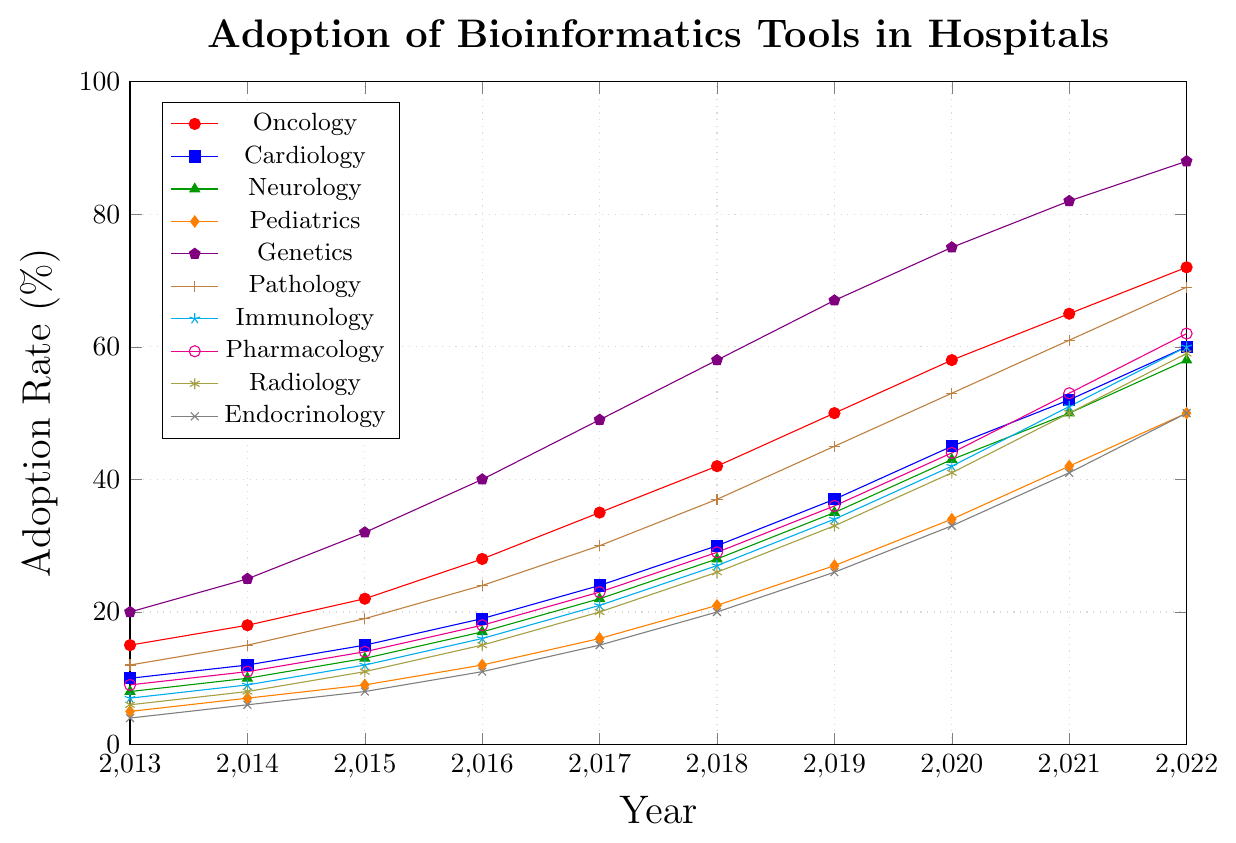What is the adoption rate of bioinformatics tools in Oncology in 2020? Look for the data point for Oncology in the year 2020 on the graph, which is marked in red and has the highest adoption rate among the lines.
Answer: 58% Which department had the lowest adoption rate in 2022? Compare the adoption rates of all departments in 2022 and identify the one with the lowest value. The lowest adoption rate in 2022 is for Endocrinology.
Answer: Endocrinology Between 2013 and 2018, which department saw the most significant increase in adoption rate? Calculate the difference in adoption rates between 2013 and 2018 for each department and compare them. Genetics saw the most significant increase, from 20% to 58%, i.e., an increase of 38%.
Answer: Genetics How does the adoption rate of Neurology in 2017 compare to Pediatrics in 2017? Compare the adoption rates for Neurology and Pediatrics in 2017. Neurology has an adoption rate of 22%, while Pediatrics has 16%.
Answer: Neurology is higher Which two departments had identical adoption rates in 2022? Scan the adoption rates in 2022 and identify the departments with matching values. Both Immunology and Cardiology had 60% in 2022.
Answer: Immunology and Cardiology What was the average adoption rate of bioinformatics tools across all departments in 2022? Sum all adoption rates for 2022 and then divide by the number of departments (10). The sum is 628%, and the average is 628/10 = 62.8%.
Answer: 62.8% By how much did the adoption rate in Pharmacology increase from 2015 to 2022? Subtract the adoption rate in 2015 from the rate in 2022 for Pharmacology. The increase is 62% - 14% = 48%.
Answer: 48% Which department had the fastest growth rate between 2019 and 2022? Calculate the growth rate for each department between 2019 and 2022 by subtracting the 2019 rate from the 2022 rate and compare these values. Genetics had the fastest growth rate, from 67% to 88%, an increase of 21%.
Answer: Genetics What was the median adoption rate of bioinformatics tools in 2013 across all departments? Arrange the 2013 adoption rates in numerical order and identify the middle value. The ordered rates are 4%, 5%, 6%, 7%, 8%, 9%, 10%, 12%, 15%, and 20%, making the median (8% + 9%)/2 = 8.5%.
Answer: 8.5% 